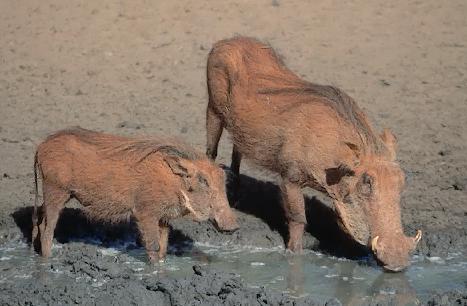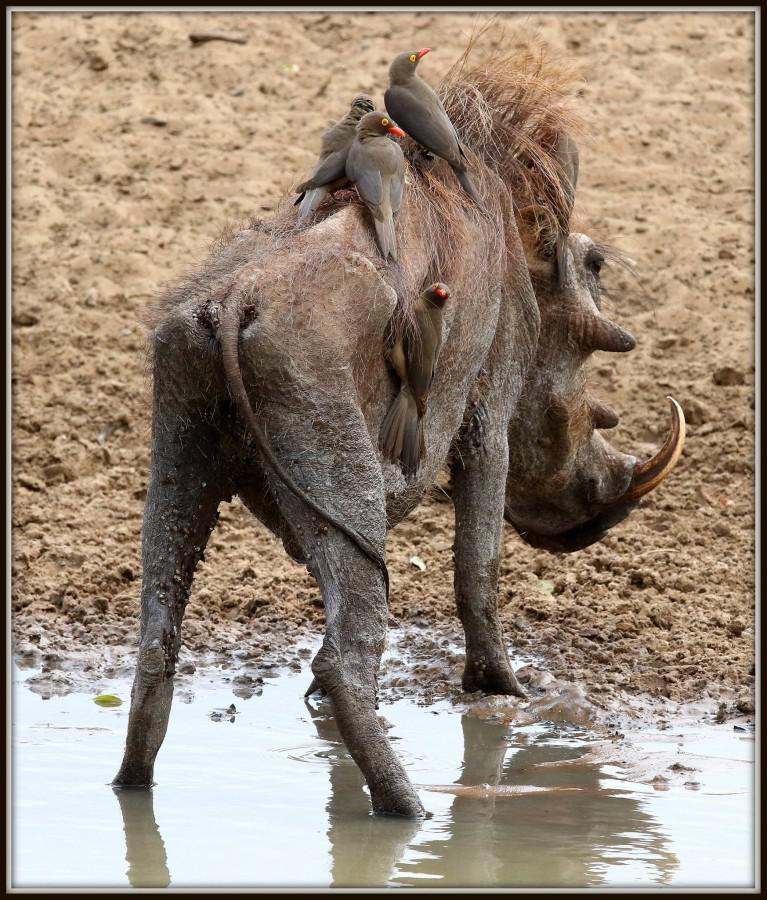The first image is the image on the left, the second image is the image on the right. Assess this claim about the two images: "There are two animals in the image on the left.". Correct or not? Answer yes or no. Yes. 